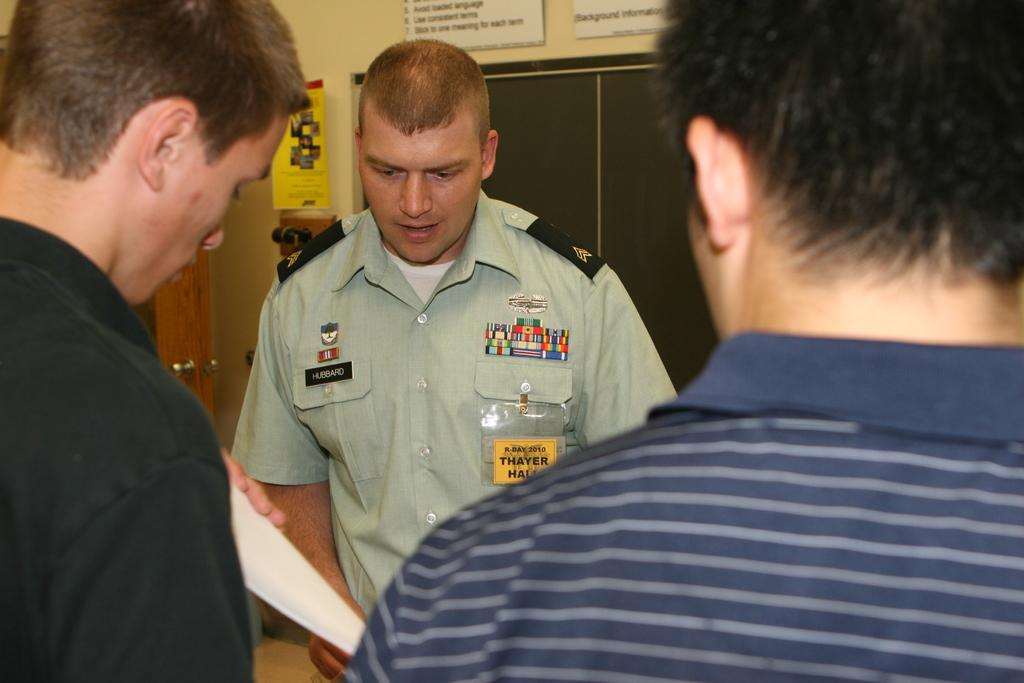<image>
Share a concise interpretation of the image provided. A soldier wearing a name badge with Hubbard on it talks to two men in civillian clothing. 